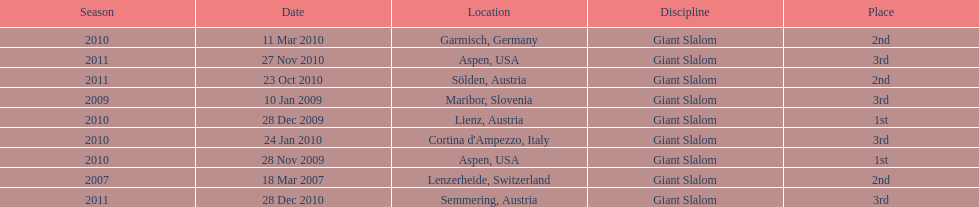What was the finishing place of the last race in december 2010? 3rd. 